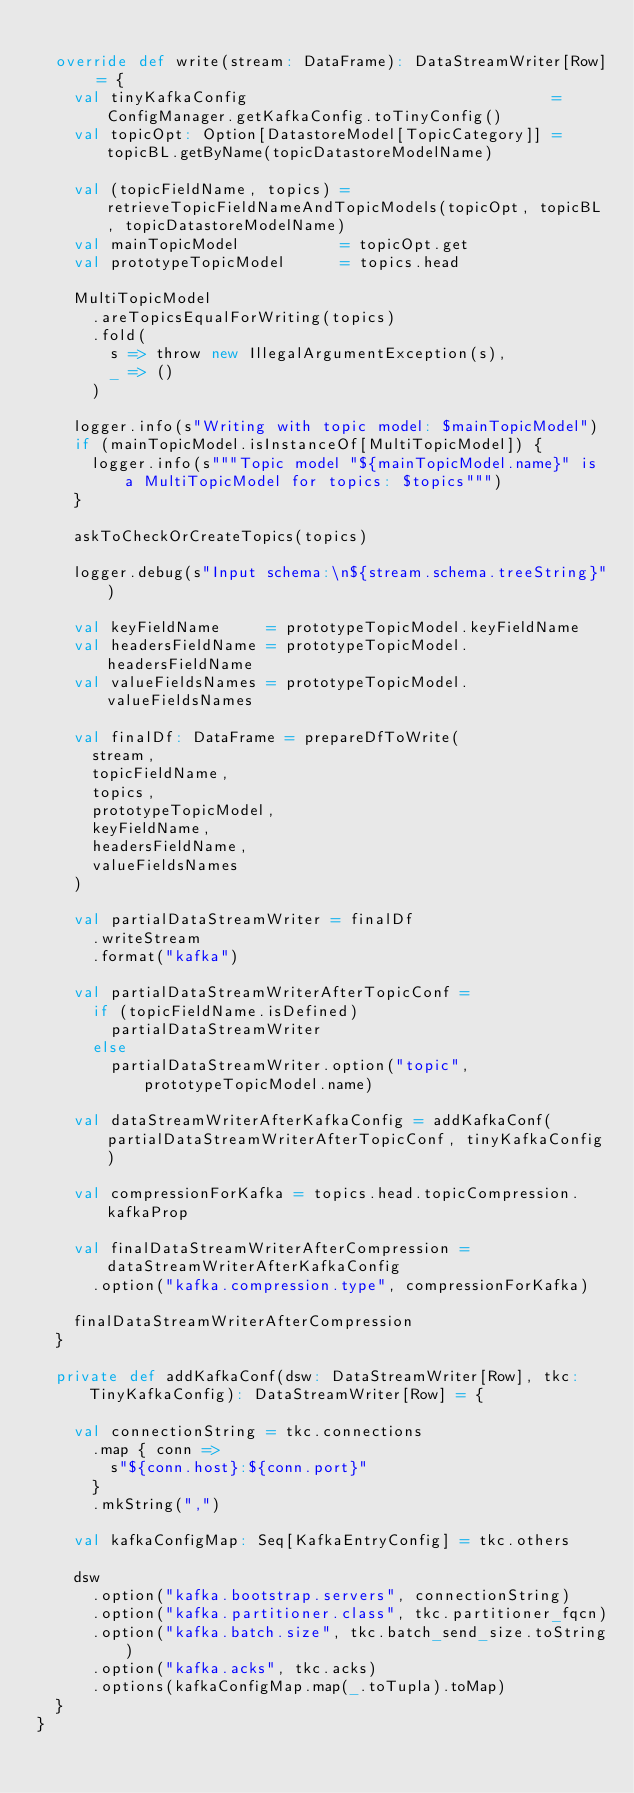<code> <loc_0><loc_0><loc_500><loc_500><_Scala_>
  override def write(stream: DataFrame): DataStreamWriter[Row] = {
    val tinyKafkaConfig                                 = ConfigManager.getKafkaConfig.toTinyConfig()
    val topicOpt: Option[DatastoreModel[TopicCategory]] = topicBL.getByName(topicDatastoreModelName)

    val (topicFieldName, topics) = retrieveTopicFieldNameAndTopicModels(topicOpt, topicBL, topicDatastoreModelName)
    val mainTopicModel           = topicOpt.get
    val prototypeTopicModel      = topics.head

    MultiTopicModel
      .areTopicsEqualForWriting(topics)
      .fold(
        s => throw new IllegalArgumentException(s),
        _ => ()
      )

    logger.info(s"Writing with topic model: $mainTopicModel")
    if (mainTopicModel.isInstanceOf[MultiTopicModel]) {
      logger.info(s"""Topic model "${mainTopicModel.name}" is a MultiTopicModel for topics: $topics""")
    }

    askToCheckOrCreateTopics(topics)

    logger.debug(s"Input schema:\n${stream.schema.treeString}")

    val keyFieldName     = prototypeTopicModel.keyFieldName
    val headersFieldName = prototypeTopicModel.headersFieldName
    val valueFieldsNames = prototypeTopicModel.valueFieldsNames

    val finalDf: DataFrame = prepareDfToWrite(
      stream,
      topicFieldName,
      topics,
      prototypeTopicModel,
      keyFieldName,
      headersFieldName,
      valueFieldsNames
    )

    val partialDataStreamWriter = finalDf
      .writeStream
      .format("kafka")

    val partialDataStreamWriterAfterTopicConf =
      if (topicFieldName.isDefined)
        partialDataStreamWriter
      else
        partialDataStreamWriter.option("topic", prototypeTopicModel.name)

    val dataStreamWriterAfterKafkaConfig = addKafkaConf(partialDataStreamWriterAfterTopicConf, tinyKafkaConfig)

    val compressionForKafka = topics.head.topicCompression.kafkaProp

    val finalDataStreamWriterAfterCompression = dataStreamWriterAfterKafkaConfig
      .option("kafka.compression.type", compressionForKafka)

    finalDataStreamWriterAfterCompression
  }

  private def addKafkaConf(dsw: DataStreamWriter[Row], tkc: TinyKafkaConfig): DataStreamWriter[Row] = {

    val connectionString = tkc.connections
      .map { conn =>
        s"${conn.host}:${conn.port}"
      }
      .mkString(",")

    val kafkaConfigMap: Seq[KafkaEntryConfig] = tkc.others

    dsw
      .option("kafka.bootstrap.servers", connectionString)
      .option("kafka.partitioner.class", tkc.partitioner_fqcn)
      .option("kafka.batch.size", tkc.batch_send_size.toString)
      .option("kafka.acks", tkc.acks)
      .options(kafkaConfigMap.map(_.toTupla).toMap)
  }
}
</code> 